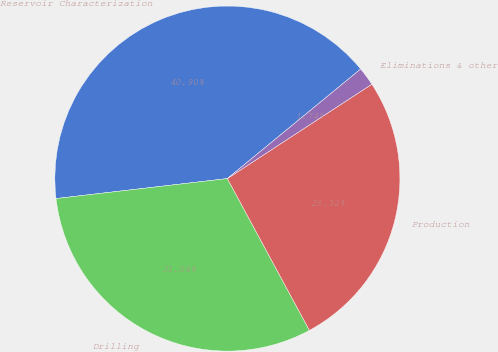<chart> <loc_0><loc_0><loc_500><loc_500><pie_chart><fcel>Reservoir Characterization<fcel>Drilling<fcel>Production<fcel>Eliminations & other<nl><fcel>40.9%<fcel>31.04%<fcel>26.32%<fcel>1.74%<nl></chart> 